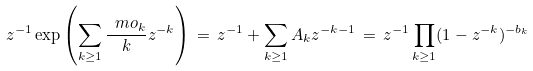Convert formula to latex. <formula><loc_0><loc_0><loc_500><loc_500>z ^ { - 1 } \exp \left ( \sum _ { k \geq 1 } \frac { \ m o _ { k } } { k } z ^ { - k } \right ) \, = \, z ^ { - 1 } + \sum _ { k \geq 1 } A _ { k } z ^ { - k - 1 } \, = \, z ^ { - 1 } \prod _ { k \geq 1 } ( 1 - z ^ { - k } ) ^ { - b _ { k } }</formula> 